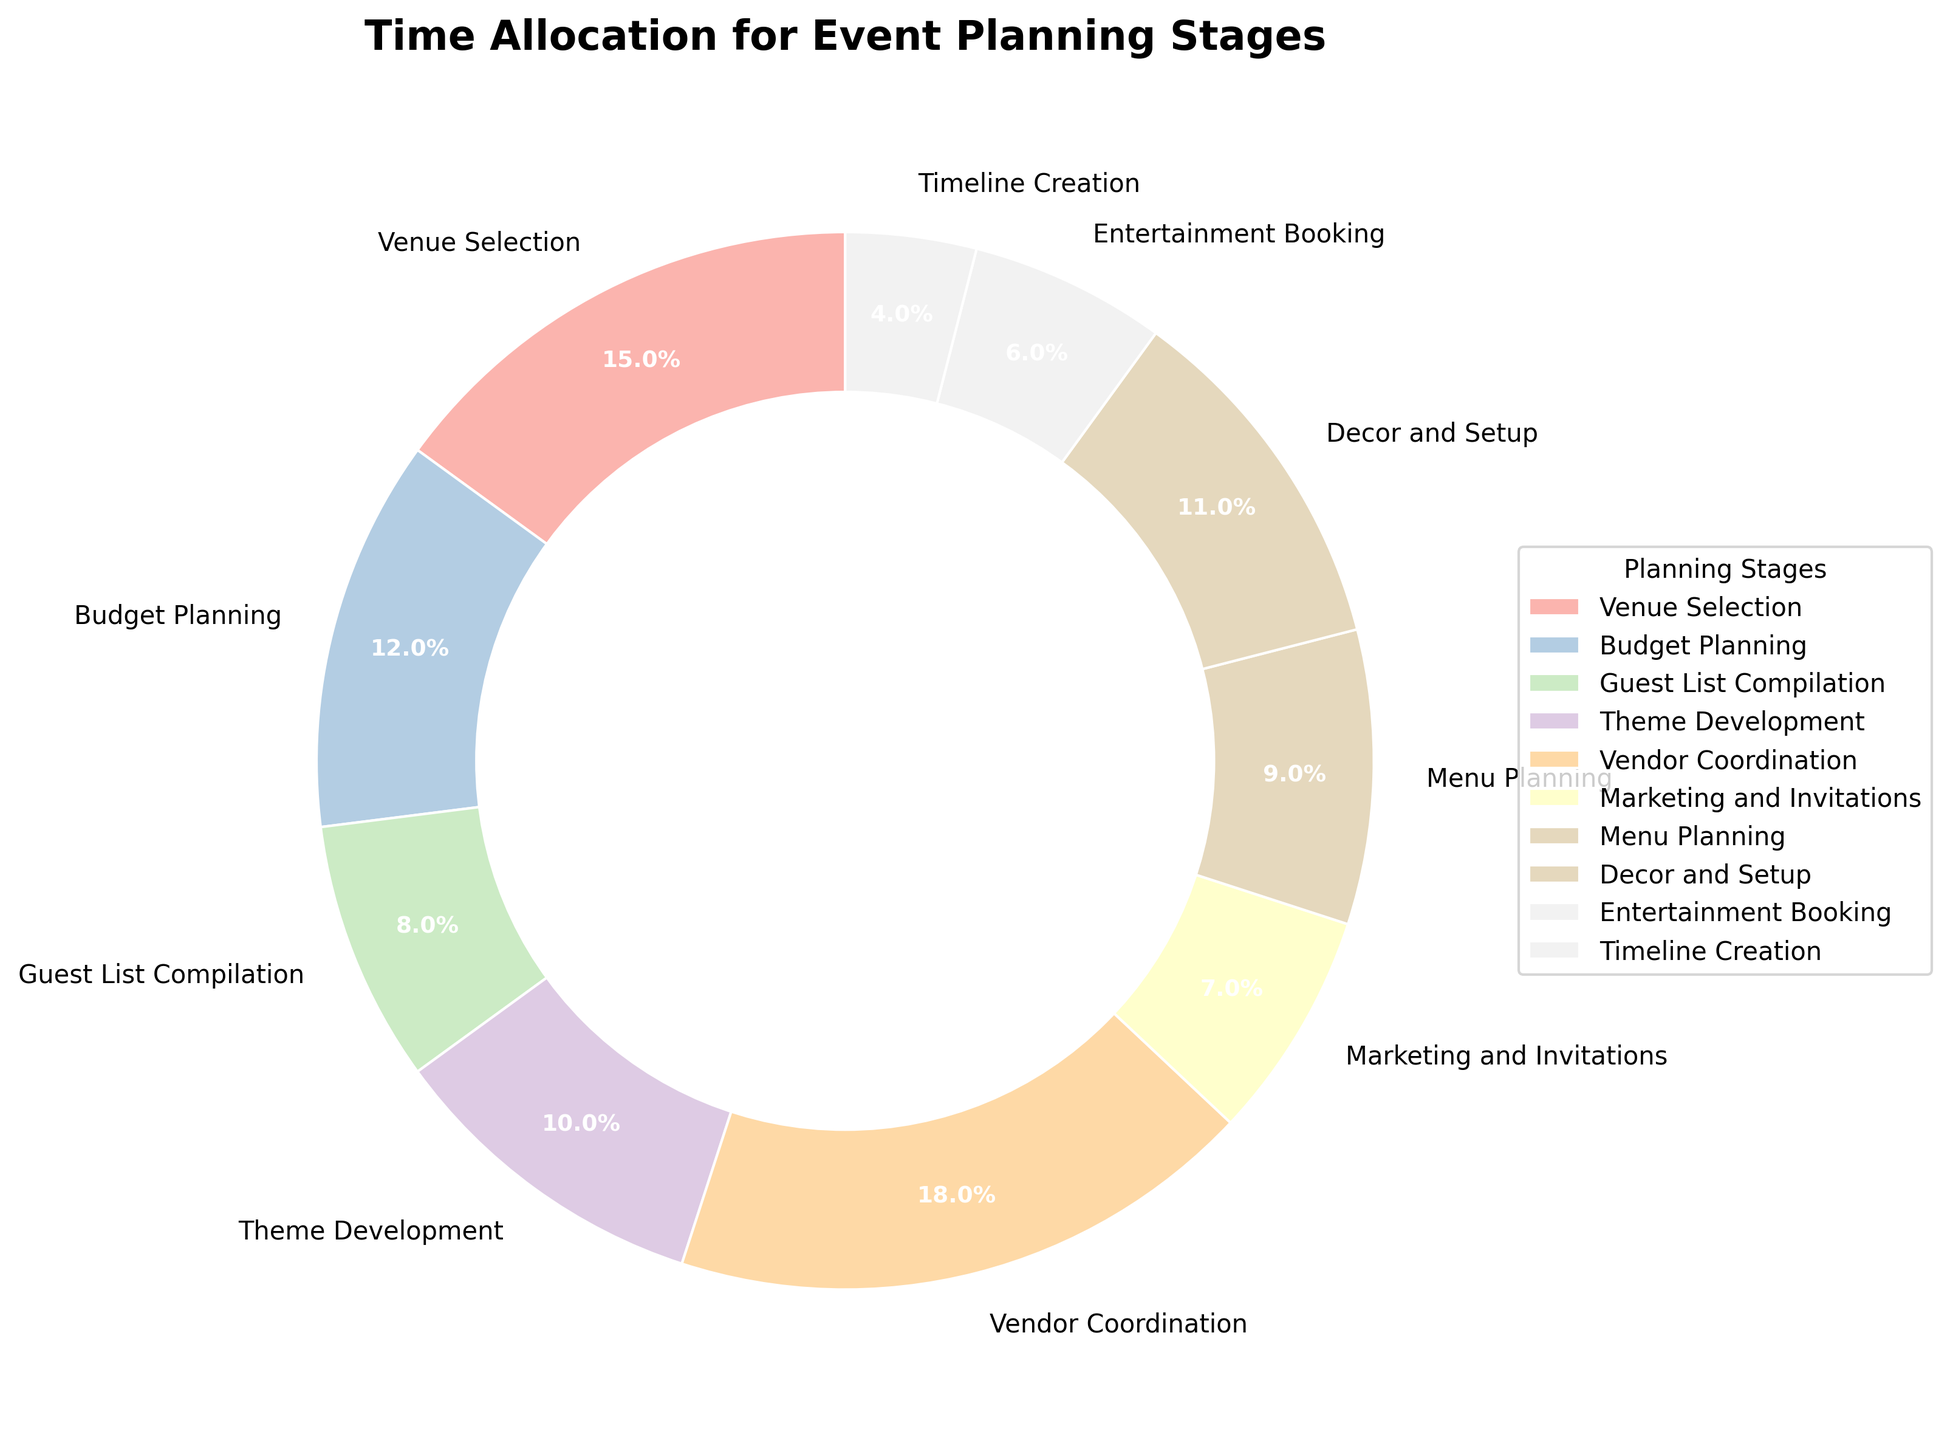Which stage has the highest time allocation? The figure shows a pie chart indicating the percentage of time allocated to different planning stages. By looking at the size of the pie slices and the labels, we can see that Vendor Coordination has the highest time allocation at 18%.
Answer: Vendor Coordination Which stage has the lowest time allocation? The figure clearly indicates the percentage of time allocated to each stage. By observing the pie chart, we can see that Timeline Creation has the lowest time allocation at 4%.
Answer: Timeline Creation What is the total time allocation for Budget Planning and Menu Planning combined? The pie chart shows the percentage of time allocated to Budget Planning as 12% and Menu Planning as 9%. Adding these values together: 12 + 9 = 21%.
Answer: 21% How much more time is allocated to Vendor Coordination compared to Entertainment Booking? The pie chart indicates Vendor Coordination has 18% and Entertainment Booking has 6%. The difference in time allocation can be calculated by subtracting the two values: 18 - 6 = 12%.
Answer: 12% Which two stages combined have a total of 25% time allocation? By examining the pie chart, we see that Guest List Compilation has 8% and Theme Development has 10%, which adds to 18%. However, Guest List Compilation (8%) and Decor and Setup (11%) sum up to 19%. Checking other combinations, only Budget Planning (12%) and Menu Planning (9%) sum to 21%. However, no two stages visibly add exactly to 25%, so no specific pair can answer this.
Answer: None Is the time allocation for 'Marketing and Invitations' greater or less than ‘Entertainment Booking’? Looking at the pie chart, ‘Marketing and Invitations’ have 7% while ‘Entertainment Booking’ has 6%. Therefore, 'Marketing and Invitations' have a higher time allocation.
Answer: Greater What is the average time allocation for Guest List Compilation, Theme Development, and Decor and Setup? The pie chart shows the time allocations for the three stages as 8%, 10%, and 11%, respectively. By summing these values: 8 + 10 + 11 = 29%, and then dividing by the number of stages (3), we get 29 / 3 ≈ 9.67%.
Answer: 9.67% What's the median value among the time allocations of all stages? Listing the time allocations in ascending order: 4%, 6%, 7%, 8%, 9%, 10%, 11%, 12%, 15%, 18%. The median is the middle value in this sorted list, so the median value is the average of the 5th (9%) and 6th (10%) values: (9 + 10) / 2 = 9.5%.
Answer: 9.5% What color is used for Budget Planning in the pie chart? The pie chart uses different colors to represent different stages. The specific color for Budget Planning can be seen directly on the pie chart.
Answer: (Describe the specific color seen) 